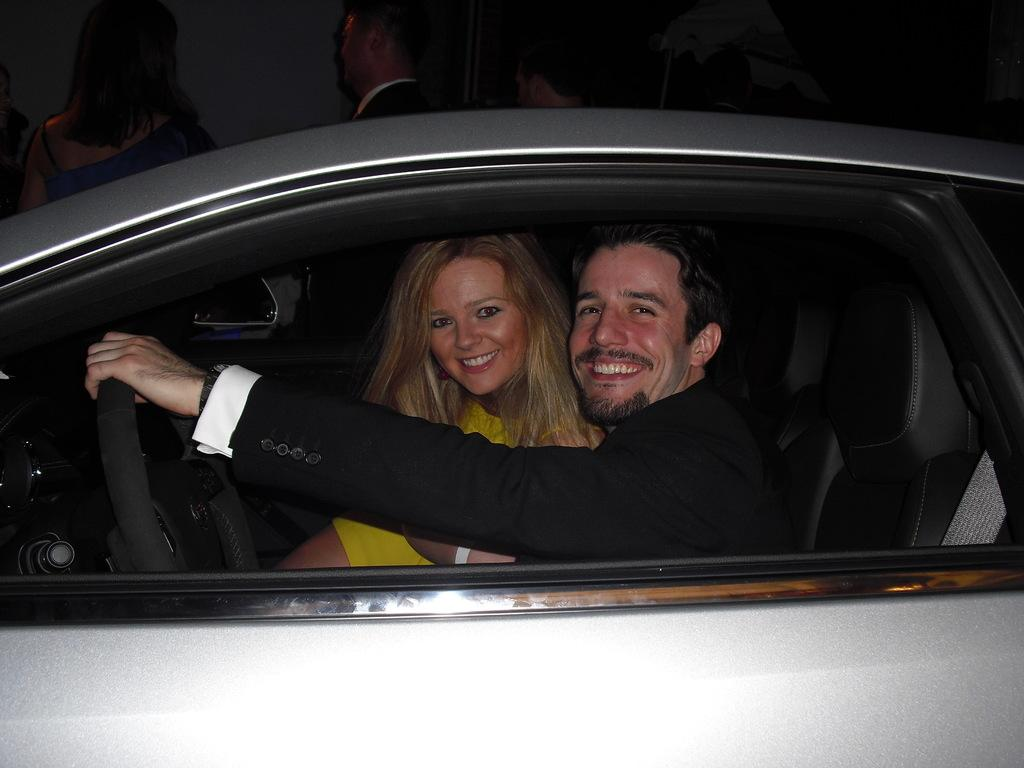How many people are in the image? There are two people in the image. What are the two people doing in the image? The two people are sitting in a car. Can you describe the people in the image? One person is a man, and the other is a woman. Both the man and the woman are smiling. What can be seen in the car that indicates it is being driven? The steering wheel is visible in the image. How much money is being exchanged between the man and the woman in the image? There is no indication of money being exchanged in the image; the man and the woman are simply sitting in a car and smiling. What type of oven can be seen in the image? There is no oven present in the image; it features two people sitting in a car. 